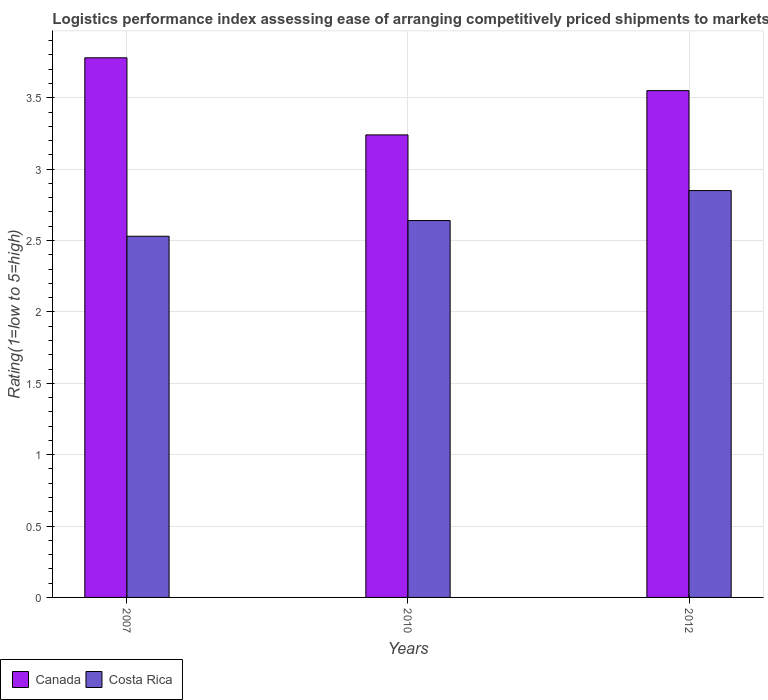How many different coloured bars are there?
Offer a very short reply. 2. What is the Logistic performance index in Canada in 2010?
Ensure brevity in your answer.  3.24. Across all years, what is the maximum Logistic performance index in Canada?
Keep it short and to the point. 3.78. Across all years, what is the minimum Logistic performance index in Costa Rica?
Your answer should be very brief. 2.53. In which year was the Logistic performance index in Canada minimum?
Your answer should be compact. 2010. What is the total Logistic performance index in Canada in the graph?
Provide a succinct answer. 10.57. What is the difference between the Logistic performance index in Costa Rica in 2007 and that in 2012?
Keep it short and to the point. -0.32. What is the difference between the Logistic performance index in Canada in 2007 and the Logistic performance index in Costa Rica in 2012?
Ensure brevity in your answer.  0.93. What is the average Logistic performance index in Costa Rica per year?
Your response must be concise. 2.67. In the year 2007, what is the difference between the Logistic performance index in Costa Rica and Logistic performance index in Canada?
Offer a terse response. -1.25. In how many years, is the Logistic performance index in Costa Rica greater than 1.8?
Your answer should be compact. 3. What is the ratio of the Logistic performance index in Costa Rica in 2010 to that in 2012?
Provide a short and direct response. 0.93. Is the Logistic performance index in Costa Rica in 2007 less than that in 2012?
Offer a terse response. Yes. Is the difference between the Logistic performance index in Costa Rica in 2007 and 2012 greater than the difference between the Logistic performance index in Canada in 2007 and 2012?
Ensure brevity in your answer.  No. What is the difference between the highest and the second highest Logistic performance index in Costa Rica?
Ensure brevity in your answer.  0.21. What is the difference between the highest and the lowest Logistic performance index in Canada?
Give a very brief answer. 0.54. In how many years, is the Logistic performance index in Costa Rica greater than the average Logistic performance index in Costa Rica taken over all years?
Your answer should be very brief. 1. What does the 1st bar from the right in 2007 represents?
Your answer should be very brief. Costa Rica. Are all the bars in the graph horizontal?
Offer a very short reply. No. Are the values on the major ticks of Y-axis written in scientific E-notation?
Provide a short and direct response. No. Does the graph contain any zero values?
Your answer should be compact. No. Where does the legend appear in the graph?
Provide a succinct answer. Bottom left. How many legend labels are there?
Offer a very short reply. 2. How are the legend labels stacked?
Make the answer very short. Horizontal. What is the title of the graph?
Your answer should be compact. Logistics performance index assessing ease of arranging competitively priced shipments to markets. What is the label or title of the Y-axis?
Your response must be concise. Rating(1=low to 5=high). What is the Rating(1=low to 5=high) of Canada in 2007?
Offer a very short reply. 3.78. What is the Rating(1=low to 5=high) of Costa Rica in 2007?
Make the answer very short. 2.53. What is the Rating(1=low to 5=high) in Canada in 2010?
Your answer should be very brief. 3.24. What is the Rating(1=low to 5=high) of Costa Rica in 2010?
Provide a short and direct response. 2.64. What is the Rating(1=low to 5=high) of Canada in 2012?
Give a very brief answer. 3.55. What is the Rating(1=low to 5=high) of Costa Rica in 2012?
Your answer should be very brief. 2.85. Across all years, what is the maximum Rating(1=low to 5=high) of Canada?
Give a very brief answer. 3.78. Across all years, what is the maximum Rating(1=low to 5=high) of Costa Rica?
Keep it short and to the point. 2.85. Across all years, what is the minimum Rating(1=low to 5=high) of Canada?
Give a very brief answer. 3.24. Across all years, what is the minimum Rating(1=low to 5=high) in Costa Rica?
Your answer should be compact. 2.53. What is the total Rating(1=low to 5=high) of Canada in the graph?
Give a very brief answer. 10.57. What is the total Rating(1=low to 5=high) of Costa Rica in the graph?
Offer a terse response. 8.02. What is the difference between the Rating(1=low to 5=high) in Canada in 2007 and that in 2010?
Provide a short and direct response. 0.54. What is the difference between the Rating(1=low to 5=high) in Costa Rica in 2007 and that in 2010?
Make the answer very short. -0.11. What is the difference between the Rating(1=low to 5=high) in Canada in 2007 and that in 2012?
Your answer should be compact. 0.23. What is the difference between the Rating(1=low to 5=high) in Costa Rica in 2007 and that in 2012?
Offer a very short reply. -0.32. What is the difference between the Rating(1=low to 5=high) of Canada in 2010 and that in 2012?
Give a very brief answer. -0.31. What is the difference between the Rating(1=low to 5=high) of Costa Rica in 2010 and that in 2012?
Your answer should be very brief. -0.21. What is the difference between the Rating(1=low to 5=high) in Canada in 2007 and the Rating(1=low to 5=high) in Costa Rica in 2010?
Give a very brief answer. 1.14. What is the difference between the Rating(1=low to 5=high) in Canada in 2010 and the Rating(1=low to 5=high) in Costa Rica in 2012?
Provide a short and direct response. 0.39. What is the average Rating(1=low to 5=high) of Canada per year?
Offer a very short reply. 3.52. What is the average Rating(1=low to 5=high) of Costa Rica per year?
Your answer should be very brief. 2.67. In the year 2007, what is the difference between the Rating(1=low to 5=high) of Canada and Rating(1=low to 5=high) of Costa Rica?
Make the answer very short. 1.25. In the year 2010, what is the difference between the Rating(1=low to 5=high) in Canada and Rating(1=low to 5=high) in Costa Rica?
Your response must be concise. 0.6. In the year 2012, what is the difference between the Rating(1=low to 5=high) in Canada and Rating(1=low to 5=high) in Costa Rica?
Ensure brevity in your answer.  0.7. What is the ratio of the Rating(1=low to 5=high) in Costa Rica in 2007 to that in 2010?
Your answer should be compact. 0.96. What is the ratio of the Rating(1=low to 5=high) of Canada in 2007 to that in 2012?
Your answer should be compact. 1.06. What is the ratio of the Rating(1=low to 5=high) of Costa Rica in 2007 to that in 2012?
Offer a terse response. 0.89. What is the ratio of the Rating(1=low to 5=high) in Canada in 2010 to that in 2012?
Make the answer very short. 0.91. What is the ratio of the Rating(1=low to 5=high) in Costa Rica in 2010 to that in 2012?
Offer a very short reply. 0.93. What is the difference between the highest and the second highest Rating(1=low to 5=high) of Canada?
Your response must be concise. 0.23. What is the difference between the highest and the second highest Rating(1=low to 5=high) of Costa Rica?
Keep it short and to the point. 0.21. What is the difference between the highest and the lowest Rating(1=low to 5=high) in Canada?
Provide a short and direct response. 0.54. What is the difference between the highest and the lowest Rating(1=low to 5=high) of Costa Rica?
Make the answer very short. 0.32. 